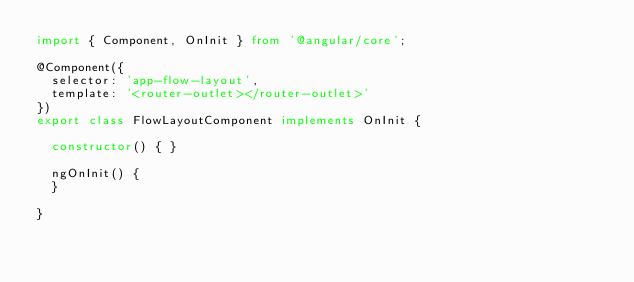Convert code to text. <code><loc_0><loc_0><loc_500><loc_500><_TypeScript_>import { Component, OnInit } from '@angular/core';

@Component({
  selector: 'app-flow-layout',
  template: '<router-outlet></router-outlet>'
})
export class FlowLayoutComponent implements OnInit {

  constructor() { }

  ngOnInit() {
  }

}
</code> 